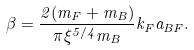<formula> <loc_0><loc_0><loc_500><loc_500>\beta = \frac { 2 ( m _ { F } + m _ { B } ) } { \pi \xi ^ { 5 / 4 } m _ { B } } k _ { F } a _ { B F } .</formula> 